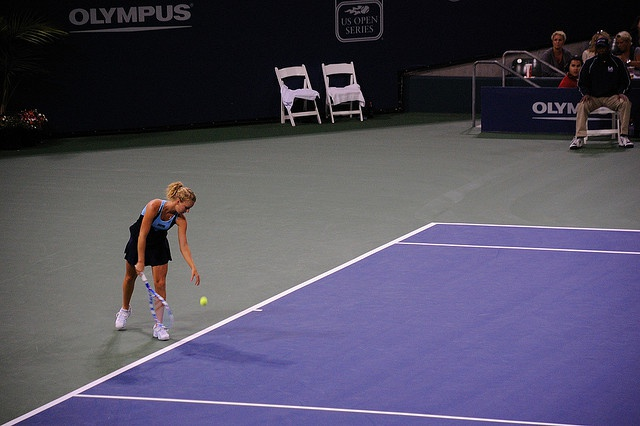Describe the objects in this image and their specific colors. I can see people in black and gray tones, people in black, gray, and maroon tones, chair in black, darkgray, and gray tones, chair in black, darkgray, and gray tones, and chair in black, gray, and darkgray tones in this image. 